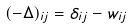<formula> <loc_0><loc_0><loc_500><loc_500>( - \Delta ) _ { i j } = \delta _ { i j } - w _ { i j }</formula> 